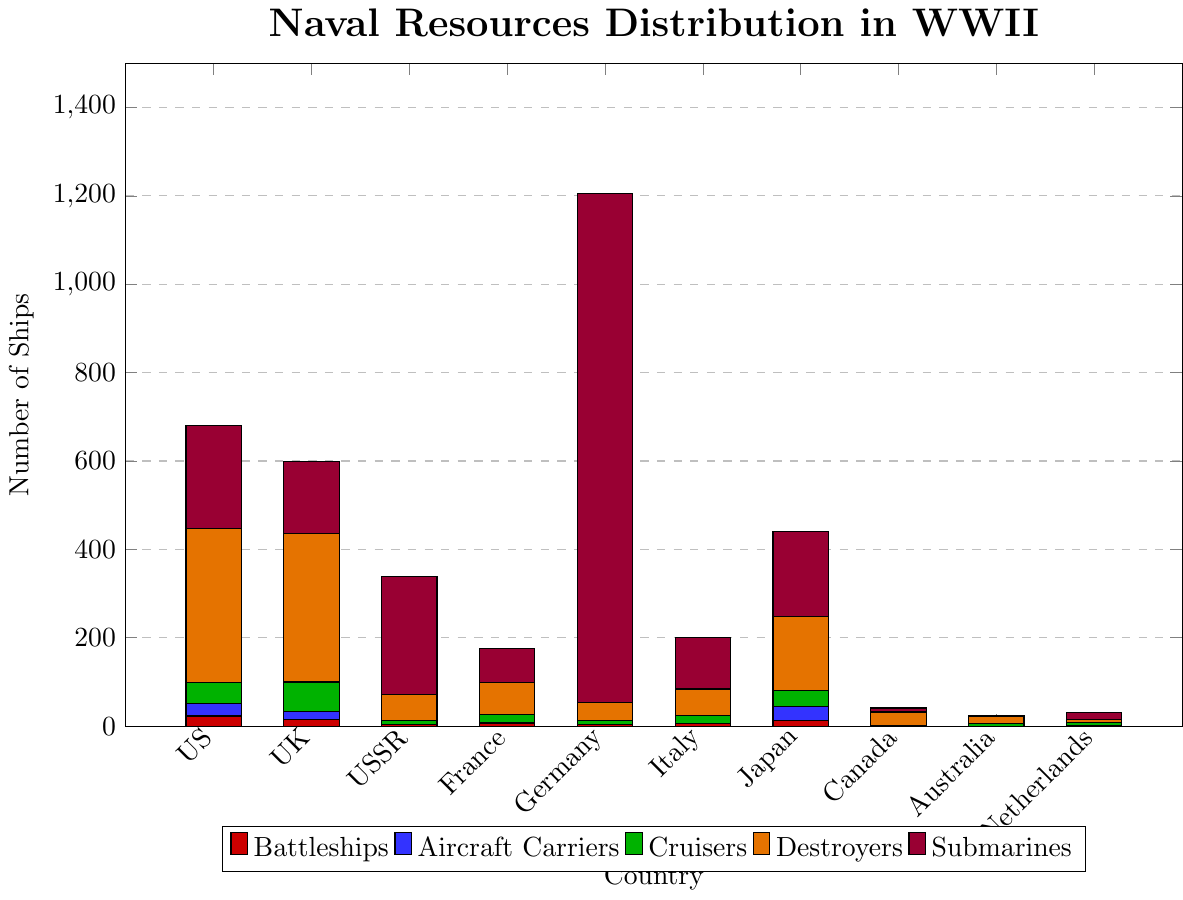What country has the highest number of destroyers? By visually inspecting the chart, the length of the orange bar representing destroyers is highest for the United States.
Answer: United States Which two countries have the same number of cruisers? By looking at the green bars representing cruisers, Italy and France both have bars of the same height.
Answer: Italy and France How many submarines does Germany have compared to the United States? Look at the purple bars representing submarines. Germany's bar is much higher than that of the United States, indicating more submarines. The chart shows Germany with 1153 submarines while the United States has 232.
Answer: 1153 vs 232 Which country has no aircraft carriers, and how many such countries are there? The blue bars represent aircraft carriers. Look for the countries with no blue bar. The Soviet Union, Germany, Italy, Canada, and Australia have no aircraft carriers, making a total of 5 countries.
Answer: 5 countries (Soviet Union, Germany, Italy, Canada, Australia) How many more battleships does the United States have compared to Japan? The red bars represent battleships. The United States has 23 and Japan has 12. Subtracting 12 from 23 gives us the difference.
Answer: 11 more battleships Which country has the tallest overall bar, and what does this indicate? The overall height of the stacked bars indicates the total number of ships across all types for each country. Germany has the tallest overall bar, indicating it has the most ships in total.
Answer: Germany What is the combined total of aircraft carriers for the United States and the United Kingdom? Adding the number of aircraft carriers for the United States (28) and the United Kingdom (19) provides the combined total. 28 + 19 = 47.
Answer: 47 How many total types of ships does Canada have? Break it down by type. Adding the values from each bar segment for Canada: 0 battleships, 0 aircraft carriers, 2 cruisers, 30 destroyers, and 9 submarines. 0 + 0 + 2 + 30 + 9 = 41.
Answer: 41 (0 battleships, 0 aircraft carriers, 2 cruisers, 30 destroyers, 9 submarines) Which country has the fewest destroyers, and how many fewer than the country with the most destroyers? By examining the orange bars for destroyers, Australia has the fewest (16). The United States has the most (349). The difference is 349 - 16 = 333.
Answer: Australia, 333 fewer destroyers What is the visual difference between the number of submarines for the Netherlands and Italy? The purple bars represent submarines. Italy's bar is taller than the Netherlands' bar. Italy has 116 submarines while the Netherlands has 15.
Answer: Italy has more submarines (116 vs 15) 